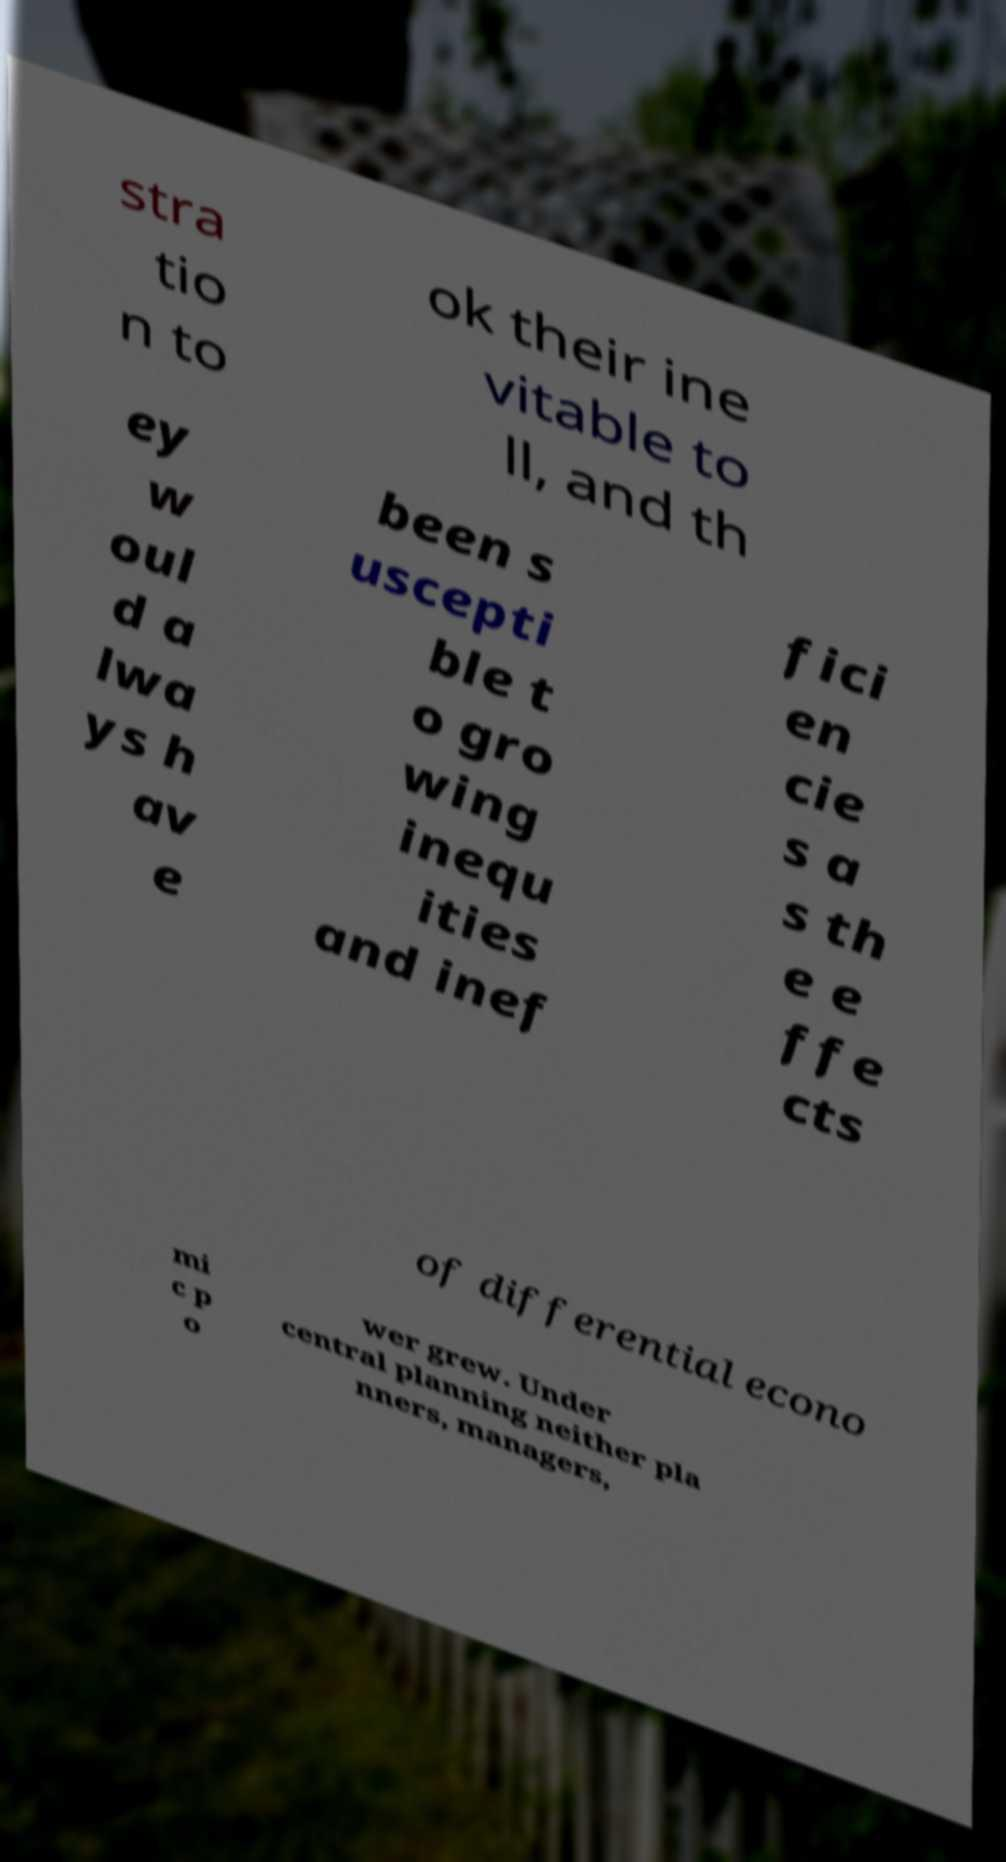Please identify and transcribe the text found in this image. stra tio n to ok their ine vitable to ll, and th ey w oul d a lwa ys h av e been s uscepti ble t o gro wing inequ ities and inef fici en cie s a s th e e ffe cts of differential econo mi c p o wer grew. Under central planning neither pla nners, managers, 